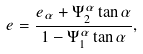<formula> <loc_0><loc_0><loc_500><loc_500>e = \frac { e _ { \alpha } + \Psi _ { 2 } ^ { \alpha } \tan \alpha } { 1 - \Psi _ { 1 } ^ { \alpha } \tan \alpha } ,</formula> 